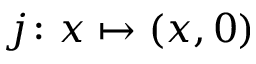<formula> <loc_0><loc_0><loc_500><loc_500>j \colon x \mapsto ( x , 0 )</formula> 